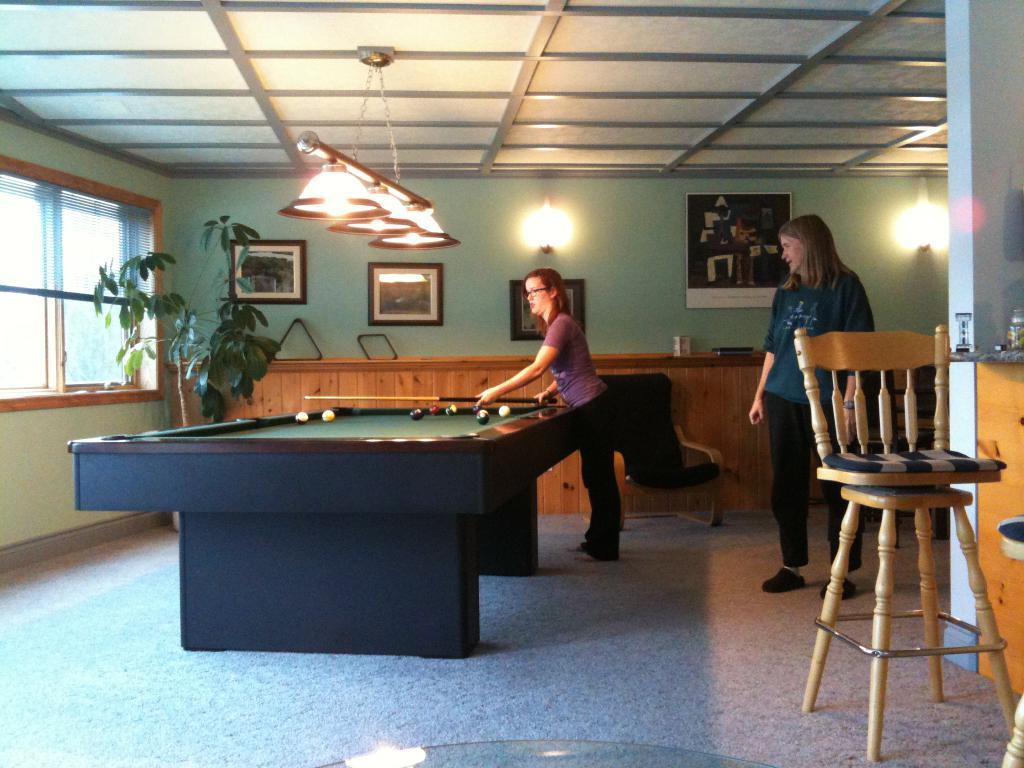How many people are in the image? There are two women in the image. What is one of the women doing in the image? One of the women is staring at the other. How many feet can be seen in the image? There is no information about feet in the image, as it only shows two women. What type of ant is crawling on the dime in the image? There is no ant or dime present in the image; it only features two women. 